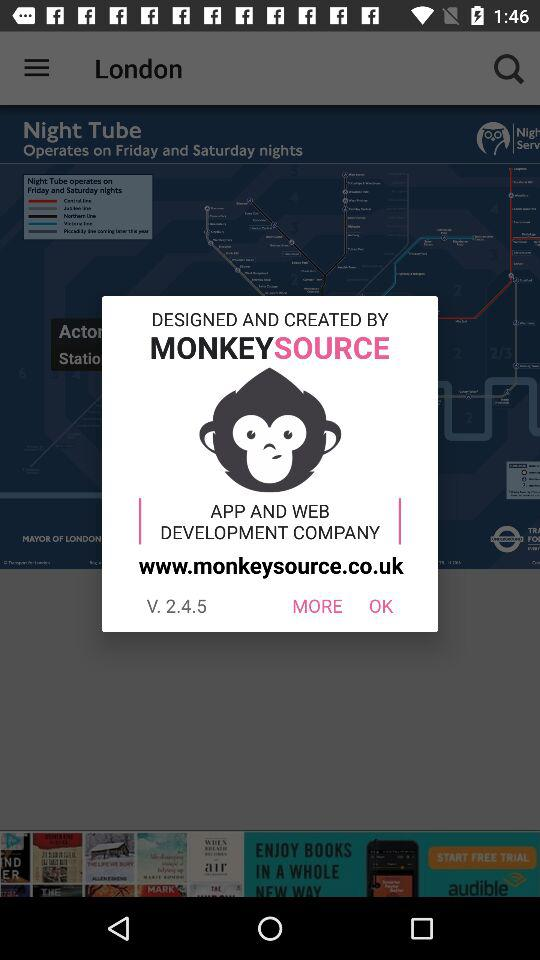Which version is used? The used version is V. 2.4.5. 